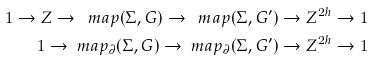<formula> <loc_0><loc_0><loc_500><loc_500>1 \to Z \to \ m a p ( \Sigma , G ) \to \ m a p ( \Sigma , G ^ { \prime } ) \to Z ^ { 2 h } \to 1 \\ 1 \to \ m a p _ { \partial } ( \Sigma , G ) \to \ m a p _ { \partial } ( \Sigma , G ^ { \prime } ) \to Z ^ { 2 h } \to 1</formula> 